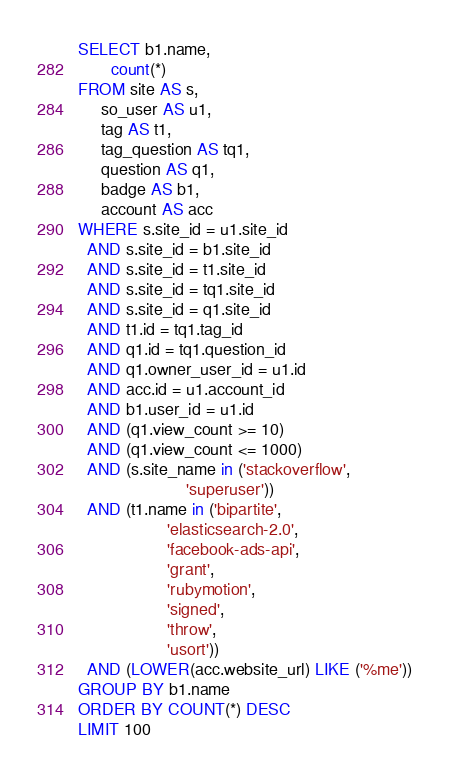Convert code to text. <code><loc_0><loc_0><loc_500><loc_500><_SQL_>SELECT b1.name,
       count(*)
FROM site AS s,
     so_user AS u1,
     tag AS t1,
     tag_question AS tq1,
     question AS q1,
     badge AS b1,
     account AS acc
WHERE s.site_id = u1.site_id
  AND s.site_id = b1.site_id
  AND s.site_id = t1.site_id
  AND s.site_id = tq1.site_id
  AND s.site_id = q1.site_id
  AND t1.id = tq1.tag_id
  AND q1.id = tq1.question_id
  AND q1.owner_user_id = u1.id
  AND acc.id = u1.account_id
  AND b1.user_id = u1.id
  AND (q1.view_count >= 10)
  AND (q1.view_count <= 1000)
  AND (s.site_name in ('stackoverflow',
                       'superuser'))
  AND (t1.name in ('bipartite',
                   'elasticsearch-2.0',
                   'facebook-ads-api',
                   'grant',
                   'rubymotion',
                   'signed',
                   'throw',
                   'usort'))
  AND (LOWER(acc.website_url) LIKE ('%me'))
GROUP BY b1.name
ORDER BY COUNT(*) DESC
LIMIT 100</code> 